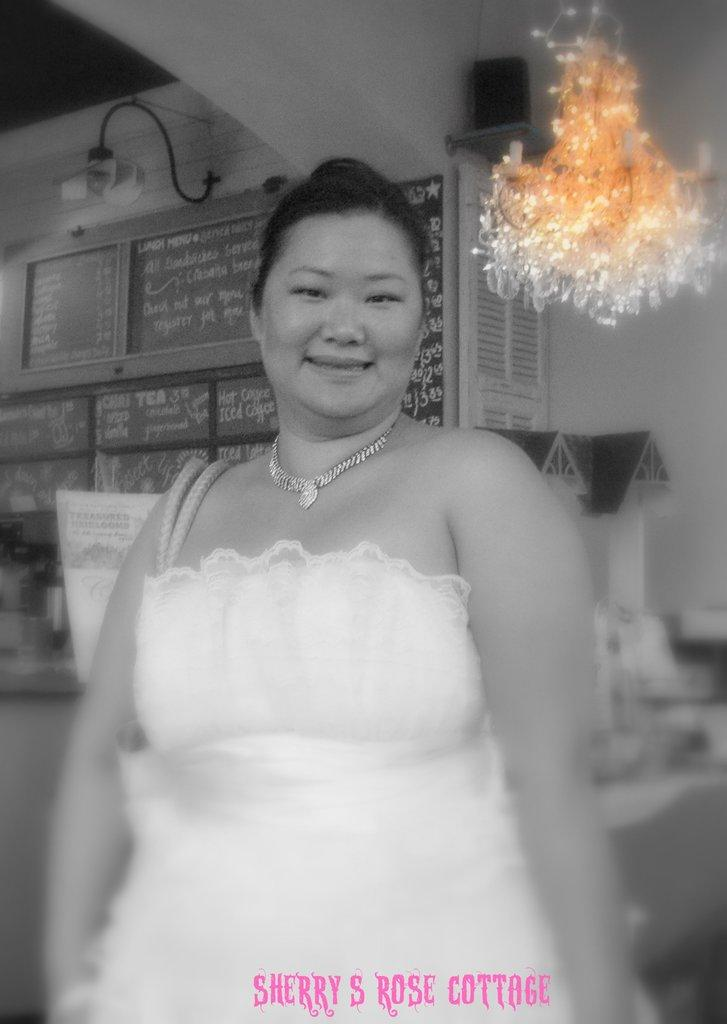Who is present in the image? There is a woman in the image. What is the woman wearing? The woman is wearing a white dress. What can be seen on the boards in the image? There are boards with text in the image. What architectural features are visible in the image? There are windows, lights, and a wall visible in the image. What type of boats can be seen in the image? There are no boats present in the image. Is there a cat involved in a fight in the image? There is no cat or fight depicted in the image. 